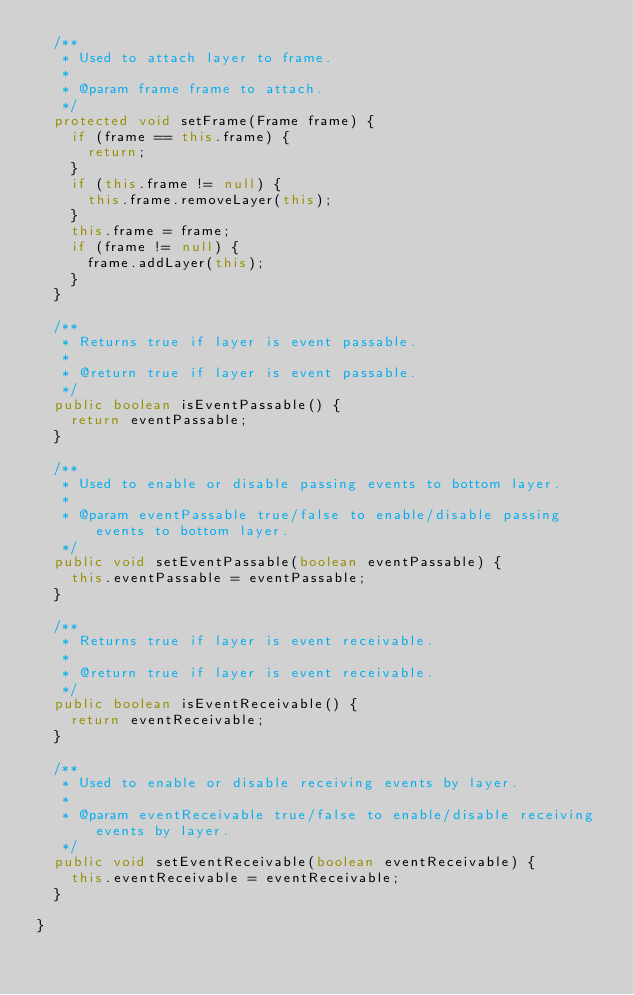Convert code to text. <code><loc_0><loc_0><loc_500><loc_500><_Java_>  /**
   * Used to attach layer to frame.
   *
   * @param frame frame to attach.
   */
  protected void setFrame(Frame frame) {
    if (frame == this.frame) {
      return;
    }
    if (this.frame != null) {
      this.frame.removeLayer(this);
    }
    this.frame = frame;
    if (frame != null) {
      frame.addLayer(this);
    }
  }

  /**
   * Returns true if layer is event passable.
   *
   * @return true if layer is event passable.
   */
  public boolean isEventPassable() {
    return eventPassable;
  }

  /**
   * Used to enable or disable passing events to bottom layer.
   *
   * @param eventPassable true/false to enable/disable passing events to bottom layer.
   */
  public void setEventPassable(boolean eventPassable) {
    this.eventPassable = eventPassable;
  }

  /**
   * Returns true if layer is event receivable.
   *
   * @return true if layer is event receivable.
   */
  public boolean isEventReceivable() {
    return eventReceivable;
  }

  /**
   * Used to enable or disable receiving events by layer.
   *
   * @param eventReceivable true/false to enable/disable receiving events by layer.
   */
  public void setEventReceivable(boolean eventReceivable) {
    this.eventReceivable = eventReceivable;
  }

}
</code> 